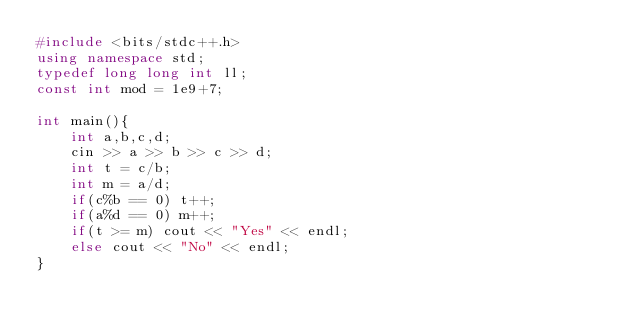Convert code to text. <code><loc_0><loc_0><loc_500><loc_500><_C++_>#include <bits/stdc++.h>
using namespace std;
typedef long long int ll;
const int mod = 1e9+7;

int main(){
    int a,b,c,d;
    cin >> a >> b >> c >> d;
    int t = c/b;
    int m = a/d;
    if(c%b == 0) t++;
    if(a%d == 0) m++;
    if(t >= m) cout << "Yes" << endl;
    else cout << "No" << endl;
}</code> 